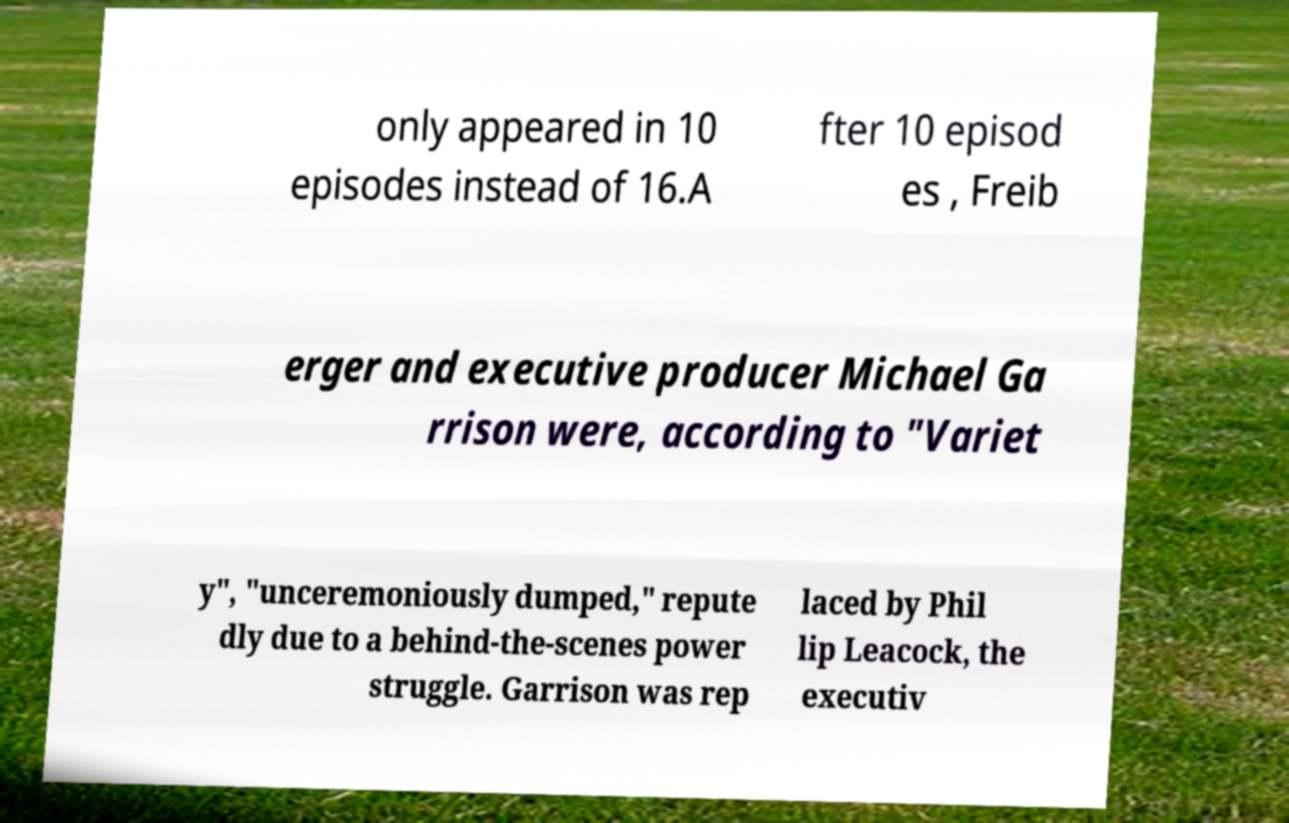Please read and relay the text visible in this image. What does it say? only appeared in 10 episodes instead of 16.A fter 10 episod es , Freib erger and executive producer Michael Ga rrison were, according to "Variet y", "unceremoniously dumped," repute dly due to a behind-the-scenes power struggle. Garrison was rep laced by Phil lip Leacock, the executiv 